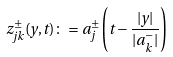Convert formula to latex. <formula><loc_0><loc_0><loc_500><loc_500>z _ { j k } ^ { \pm } ( y , t ) \colon = a _ { j } ^ { \pm } \left ( t - \frac { | y | } { | a _ { k } ^ { - } | } \right )</formula> 